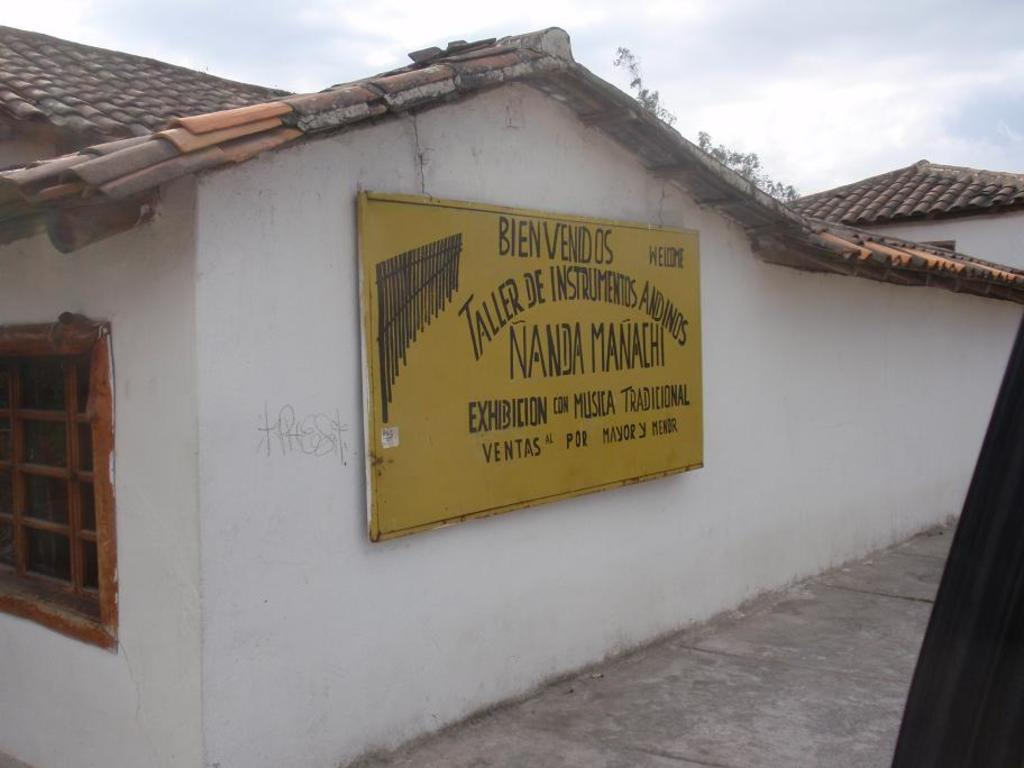Provide a one-sentence caption for the provided image. a white house with bienvenidos in black and yellow on it. 